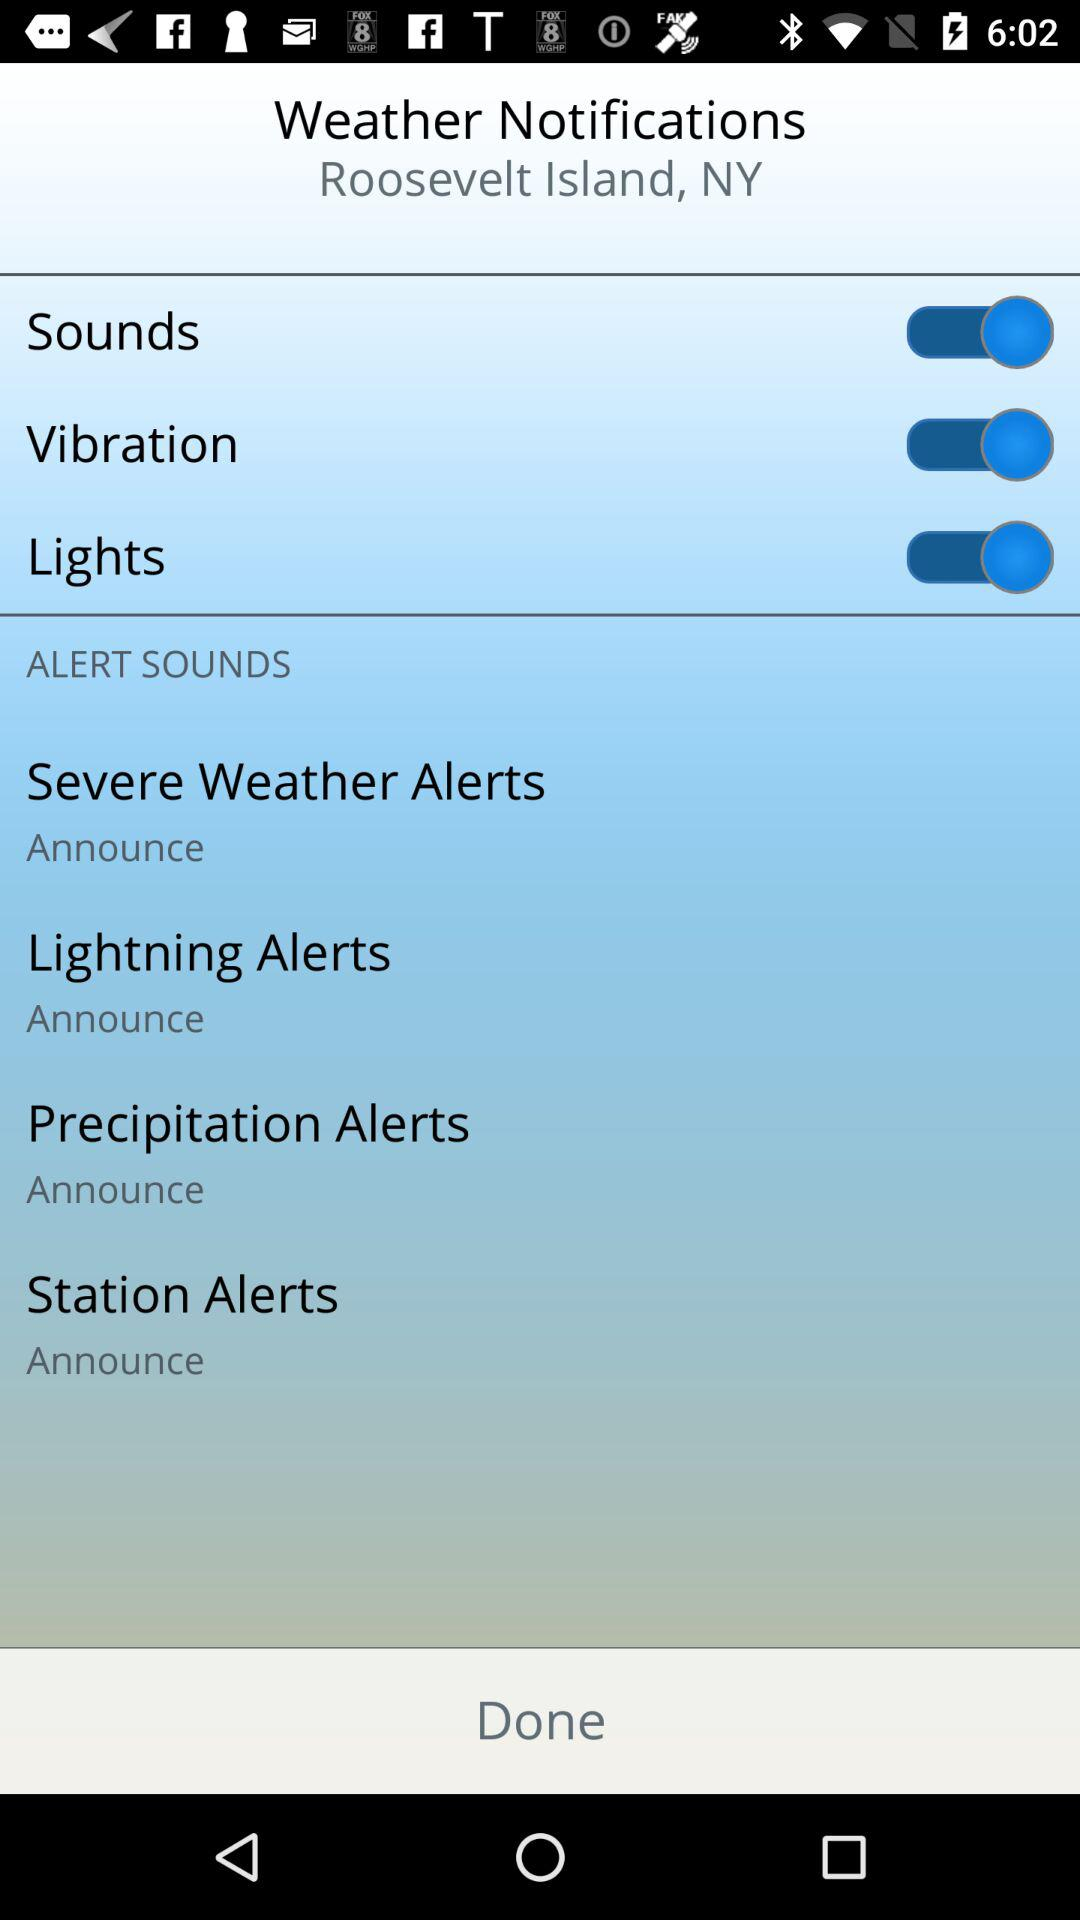How many alert types are there?
Answer the question using a single word or phrase. 4 